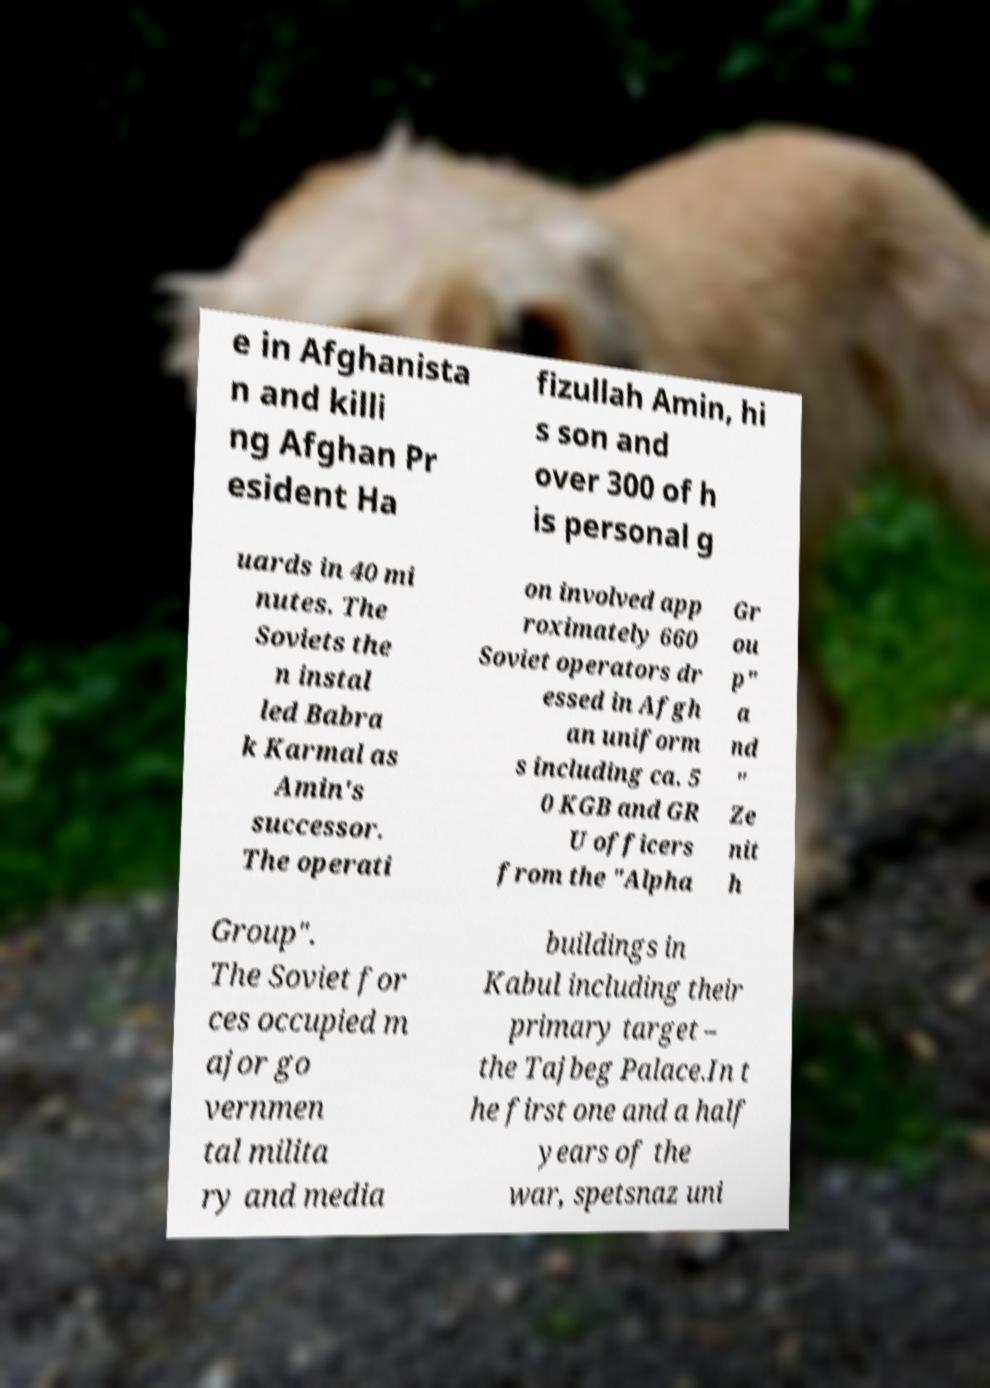Could you assist in decoding the text presented in this image and type it out clearly? e in Afghanista n and killi ng Afghan Pr esident Ha fizullah Amin, hi s son and over 300 of h is personal g uards in 40 mi nutes. The Soviets the n instal led Babra k Karmal as Amin's successor. The operati on involved app roximately 660 Soviet operators dr essed in Afgh an uniform s including ca. 5 0 KGB and GR U officers from the "Alpha Gr ou p" a nd " Ze nit h Group". The Soviet for ces occupied m ajor go vernmen tal milita ry and media buildings in Kabul including their primary target – the Tajbeg Palace.In t he first one and a half years of the war, spetsnaz uni 